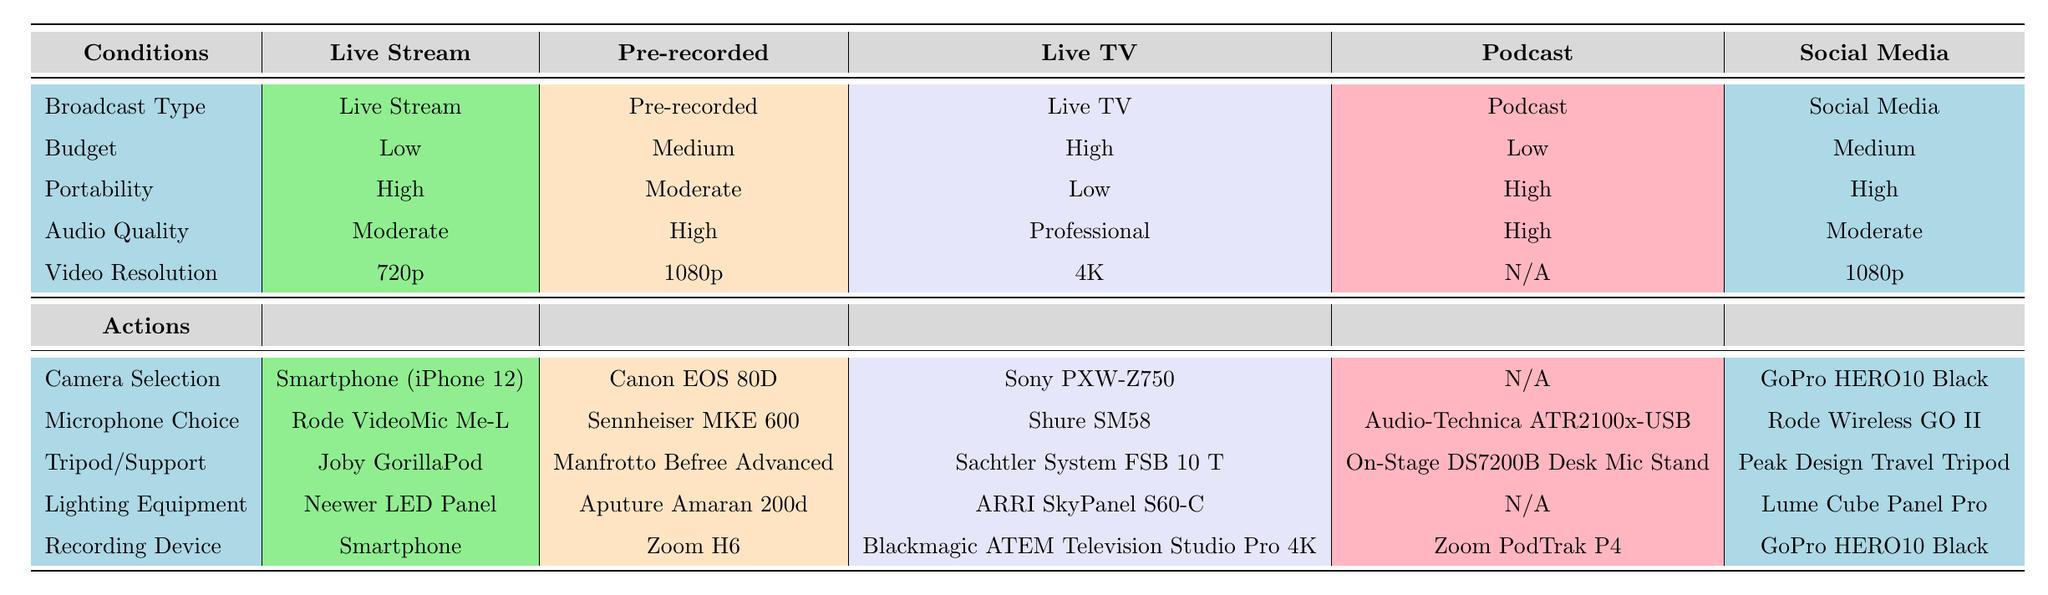What camera is recommended for a high-budget Live TV broadcast? The table specifies the Camera Selection for Live TV under the high-budget category as "Sony PXW-Z750."
Answer: Sony PXW-Z750 Is a smartphone suitable for recording podcasts, according to the table? The table has listed "N/A" under Camera Selection for Podcasts, indicating that no camera is recommended. It suggests using a dedicated recording device instead.
Answer: No What is the video resolution for pre-recorded broadcasts? The table shows the Video Resolution for Pre-recorded broadcasts as "1080p."
Answer: 1080p Which broadcast type requires the highest audio quality? By reviewing the Audio Quality column, "Professional" is the highest quality listed, which corresponds to the Live TV broadcast type.
Answer: Live TV If someone wants to do a Live Stream, what is the average budget range based on the provided data? The table indicates that the budget for Live Stream broadcasts is "Low." There are no other budget ranges listed under this broadcast type. Since no numeric values are provided, the average cannot be calculated; thus, it will remain as specified in the table.
Answer: Low Which equipment is universally applicable for both social media and live stream broadcasts? The table details different equipment for these broadcast types, but it is noted that "GoPro HERO10 Black" is used as both the Camera Selection and Recording Device for Social Media, while the Live Stream has different specified equipment. Therefore, there is no universally applicable equipment.
Answer: None For a high-budget project, which lighting equipment should be used according to the table? Under the high-budget category for Live TV, the recommended Lighting Equipment is "ARRI SkyPanel S60-C."
Answer: ARRI SkyPanel S60-C What is the difference in video resolution between Live Stream and Pre-recorded broadcasts? The Video Resolution for Live Stream is "720p" and for Pre-recorded broadcasts it's "1080p." The difference is calculated as 1080p - 720p, which is 360p.
Answer: 360p What kind of tripod support is suggested for a live stream? According to the table, the Tripod/Support recommended for a Live Stream is "Joby GorillaPod."
Answer: Joby GorillaPod 